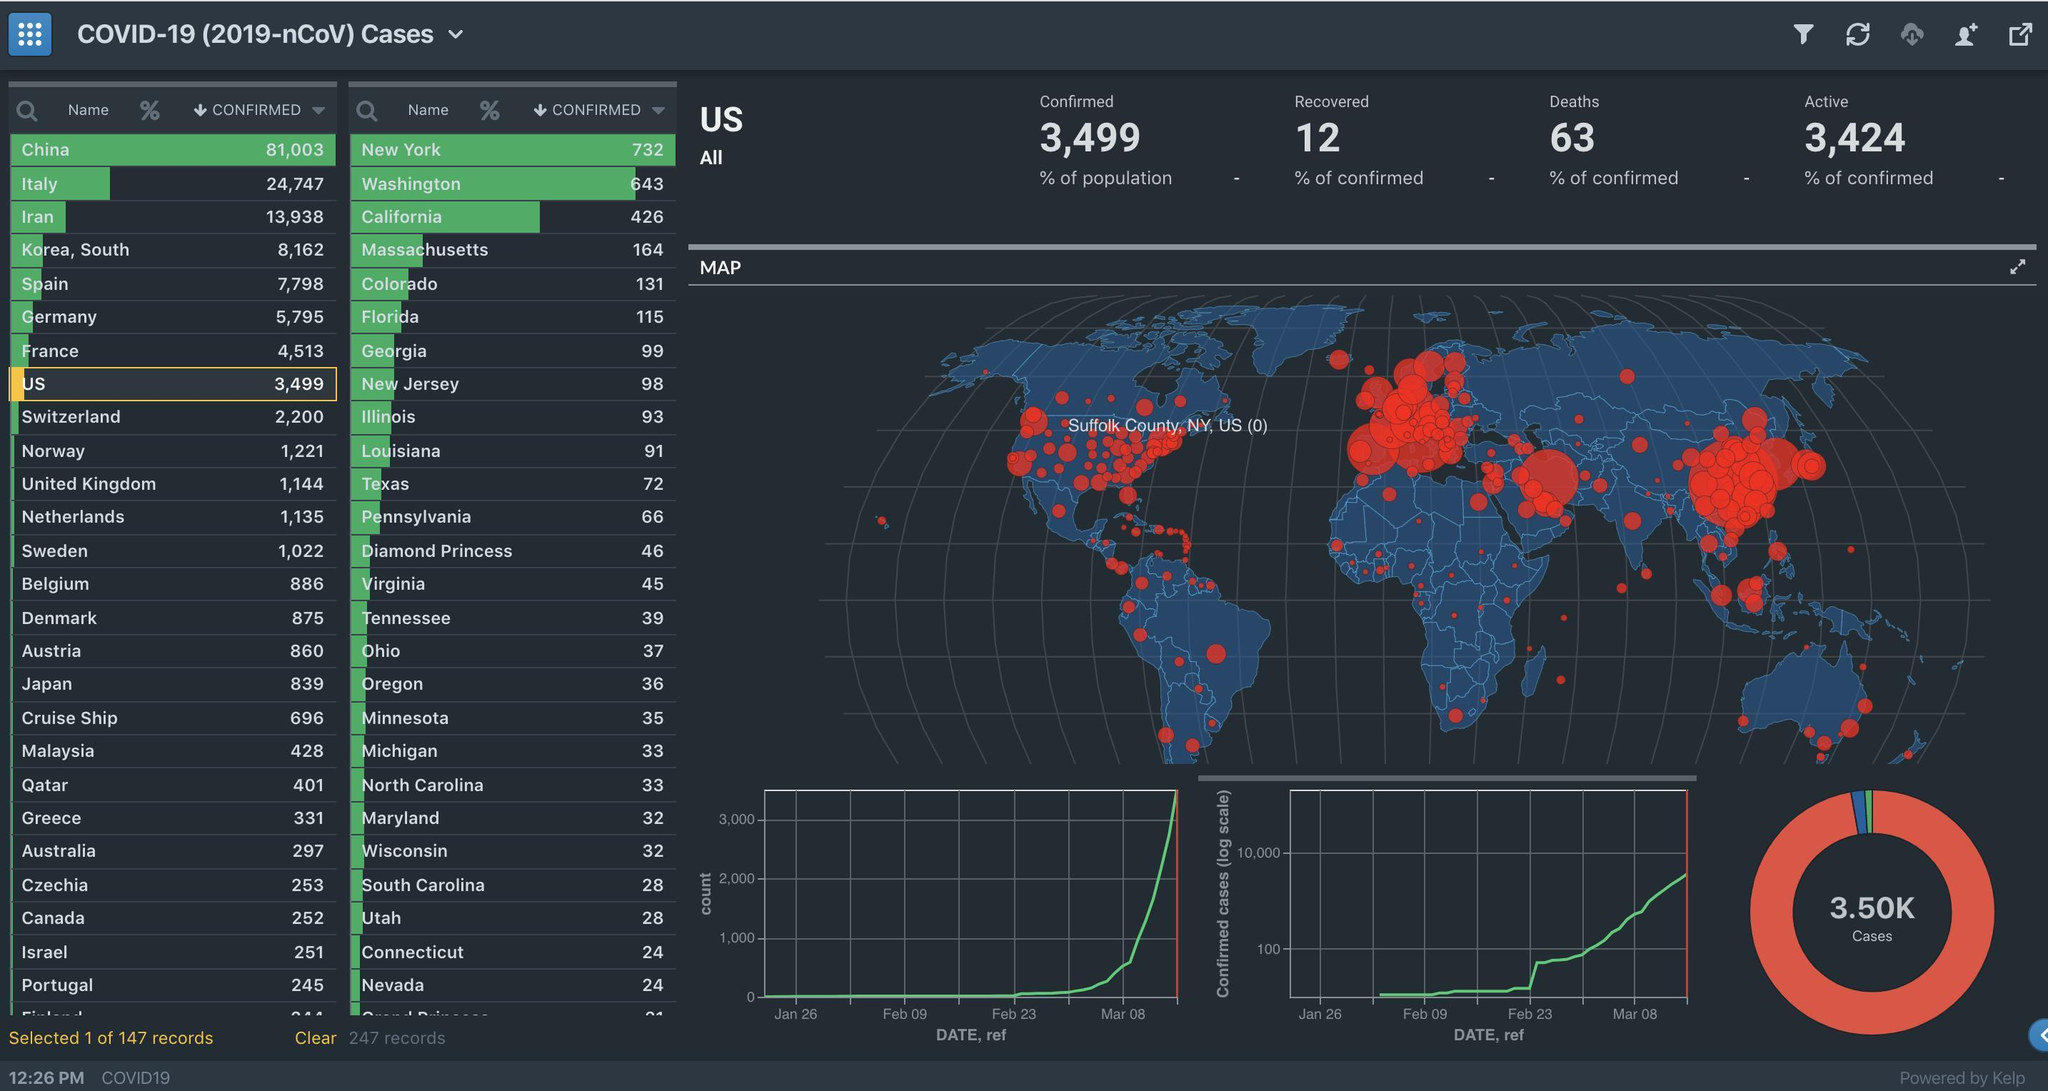How many more COVID-19 cases are reported in Iran than US in the infographic?
Answer the question with a short phrase. 10,439 How many states have number of cases between 25 and 40? 10 Which state in US has the most number of cases? New York Which state in US has the sixth highest number of cases? Florida How many cases are being reported in cruise ships across the world? 696 How many states report more than a fifty COVID-19 cases according to the infographic? 12 How many more COVID-19 cases are reported in Florida than New Jersey in the infographic? 17 Which state in US has the fourth highest number of cases? Massachusetts How many states report more COVID-19 cases than Georgia according to the infographic? 6 Which state in US has the third highest number of cases? California How many more COVID-19 cases are reported in Massachusetts than New Jersey in the infographic? 66 Which European country has the most number of cases according to the infographic? Spain How many states report more than a five hundred COVID-19 cases according to the infographic? 2 How many more COVID-19 cases are reported in China than US in the infographic? 77,504 How many countries report more than 10,000 COVID-19 cases according to the infographic? 3 What is the difference in Confirmed cases and Active cases according to the infographic? 75 How many states report more than a hundred COVID-19 cases according to the infographic? 6 How many countries report more than a thousand COVID-19 cases according to the infographic? 13 Which cruise ship in US has more than 25 cases according to the infographic? Diamond Princess How many states report more COVID-19 cases than Pennsylvania according to the infographic? 11 